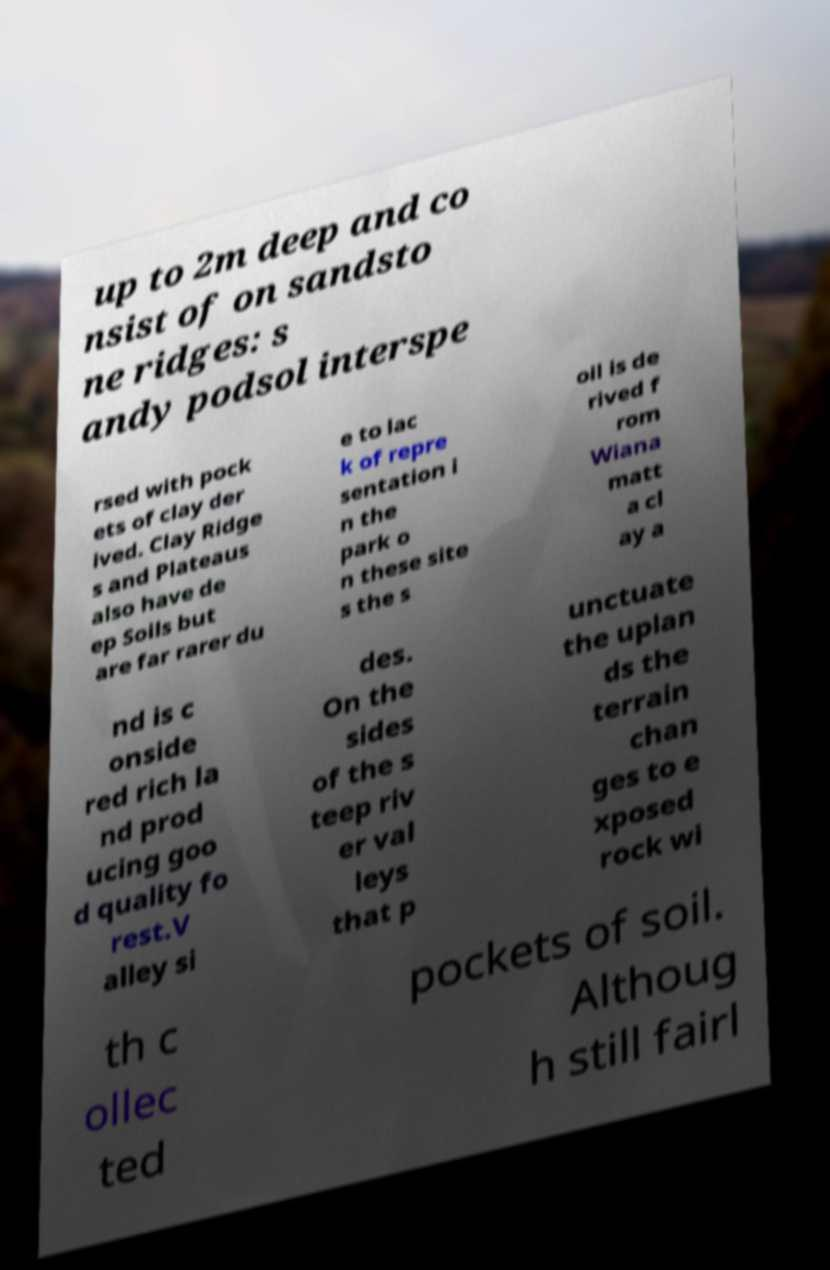Please read and relay the text visible in this image. What does it say? up to 2m deep and co nsist of on sandsto ne ridges: s andy podsol interspe rsed with pock ets of clay der ived. Clay Ridge s and Plateaus also have de ep Soils but are far rarer du e to lac k of repre sentation i n the park o n these site s the s oil is de rived f rom Wiana matt a cl ay a nd is c onside red rich la nd prod ucing goo d quality fo rest.V alley si des. On the sides of the s teep riv er val leys that p unctuate the uplan ds the terrain chan ges to e xposed rock wi th c ollec ted pockets of soil. Althoug h still fairl 